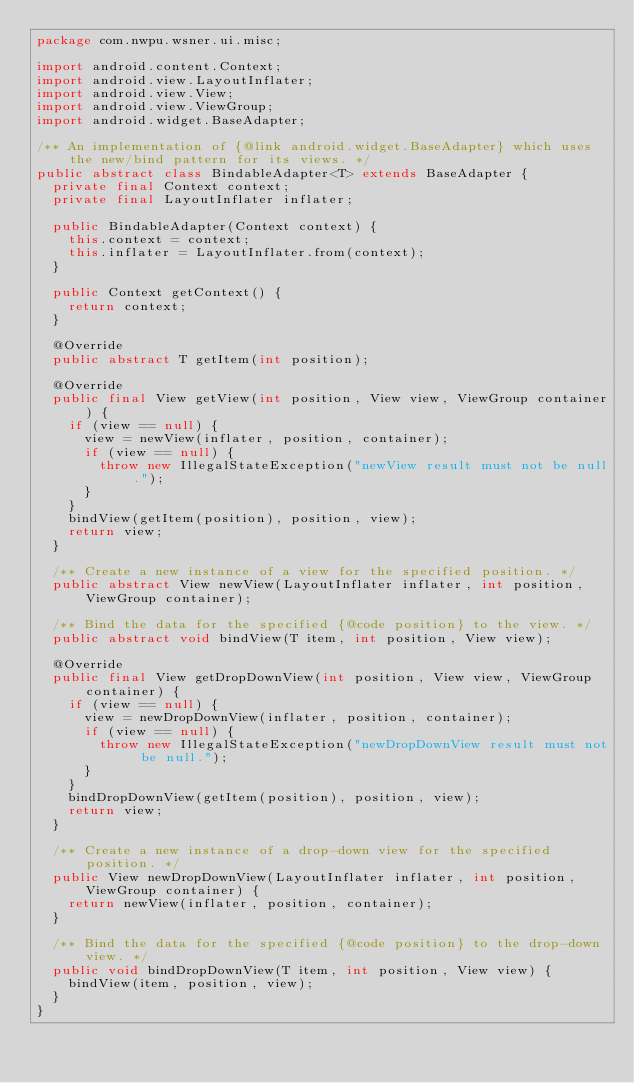<code> <loc_0><loc_0><loc_500><loc_500><_Java_>package com.nwpu.wsner.ui.misc;

import android.content.Context;
import android.view.LayoutInflater;
import android.view.View;
import android.view.ViewGroup;
import android.widget.BaseAdapter;

/** An implementation of {@link android.widget.BaseAdapter} which uses the new/bind pattern for its views. */
public abstract class BindableAdapter<T> extends BaseAdapter {
  private final Context context;
  private final LayoutInflater inflater;

  public BindableAdapter(Context context) {
    this.context = context;
    this.inflater = LayoutInflater.from(context);
  }

  public Context getContext() {
    return context;
  }

  @Override
  public abstract T getItem(int position);

  @Override
  public final View getView(int position, View view, ViewGroup container) {
    if (view == null) {
      view = newView(inflater, position, container);
      if (view == null) {
        throw new IllegalStateException("newView result must not be null.");
      }
    }
    bindView(getItem(position), position, view);
    return view;
  }

  /** Create a new instance of a view for the specified position. */
  public abstract View newView(LayoutInflater inflater, int position, ViewGroup container);

  /** Bind the data for the specified {@code position} to the view. */
  public abstract void bindView(T item, int position, View view);

  @Override
  public final View getDropDownView(int position, View view, ViewGroup container) {
    if (view == null) {
      view = newDropDownView(inflater, position, container);
      if (view == null) {
        throw new IllegalStateException("newDropDownView result must not be null.");
      }
    }
    bindDropDownView(getItem(position), position, view);
    return view;
  }

  /** Create a new instance of a drop-down view for the specified position. */
  public View newDropDownView(LayoutInflater inflater, int position, ViewGroup container) {
    return newView(inflater, position, container);
  }

  /** Bind the data for the specified {@code position} to the drop-down view. */
  public void bindDropDownView(T item, int position, View view) {
    bindView(item, position, view);
  }
}
</code> 